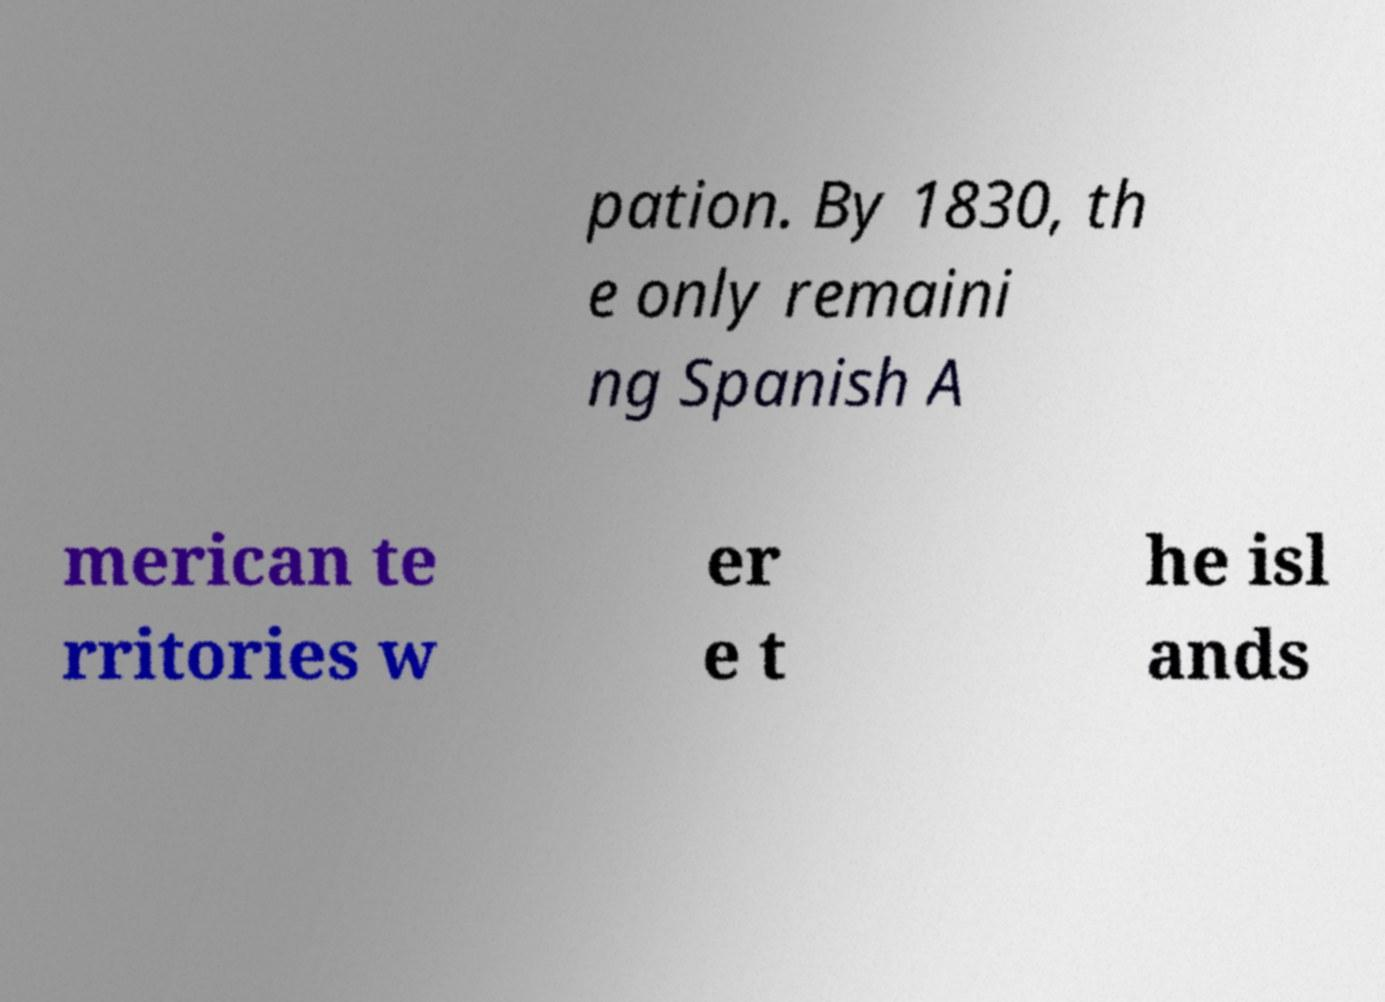Please identify and transcribe the text found in this image. pation. By 1830, th e only remaini ng Spanish A merican te rritories w er e t he isl ands 